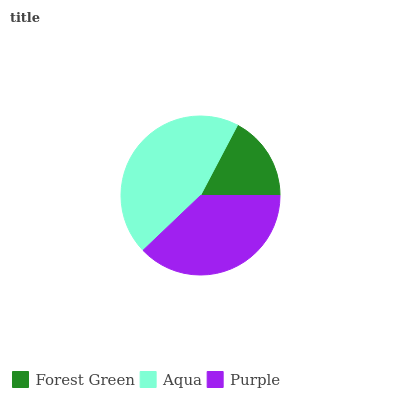Is Forest Green the minimum?
Answer yes or no. Yes. Is Aqua the maximum?
Answer yes or no. Yes. Is Purple the minimum?
Answer yes or no. No. Is Purple the maximum?
Answer yes or no. No. Is Aqua greater than Purple?
Answer yes or no. Yes. Is Purple less than Aqua?
Answer yes or no. Yes. Is Purple greater than Aqua?
Answer yes or no. No. Is Aqua less than Purple?
Answer yes or no. No. Is Purple the high median?
Answer yes or no. Yes. Is Purple the low median?
Answer yes or no. Yes. Is Forest Green the high median?
Answer yes or no. No. Is Forest Green the low median?
Answer yes or no. No. 